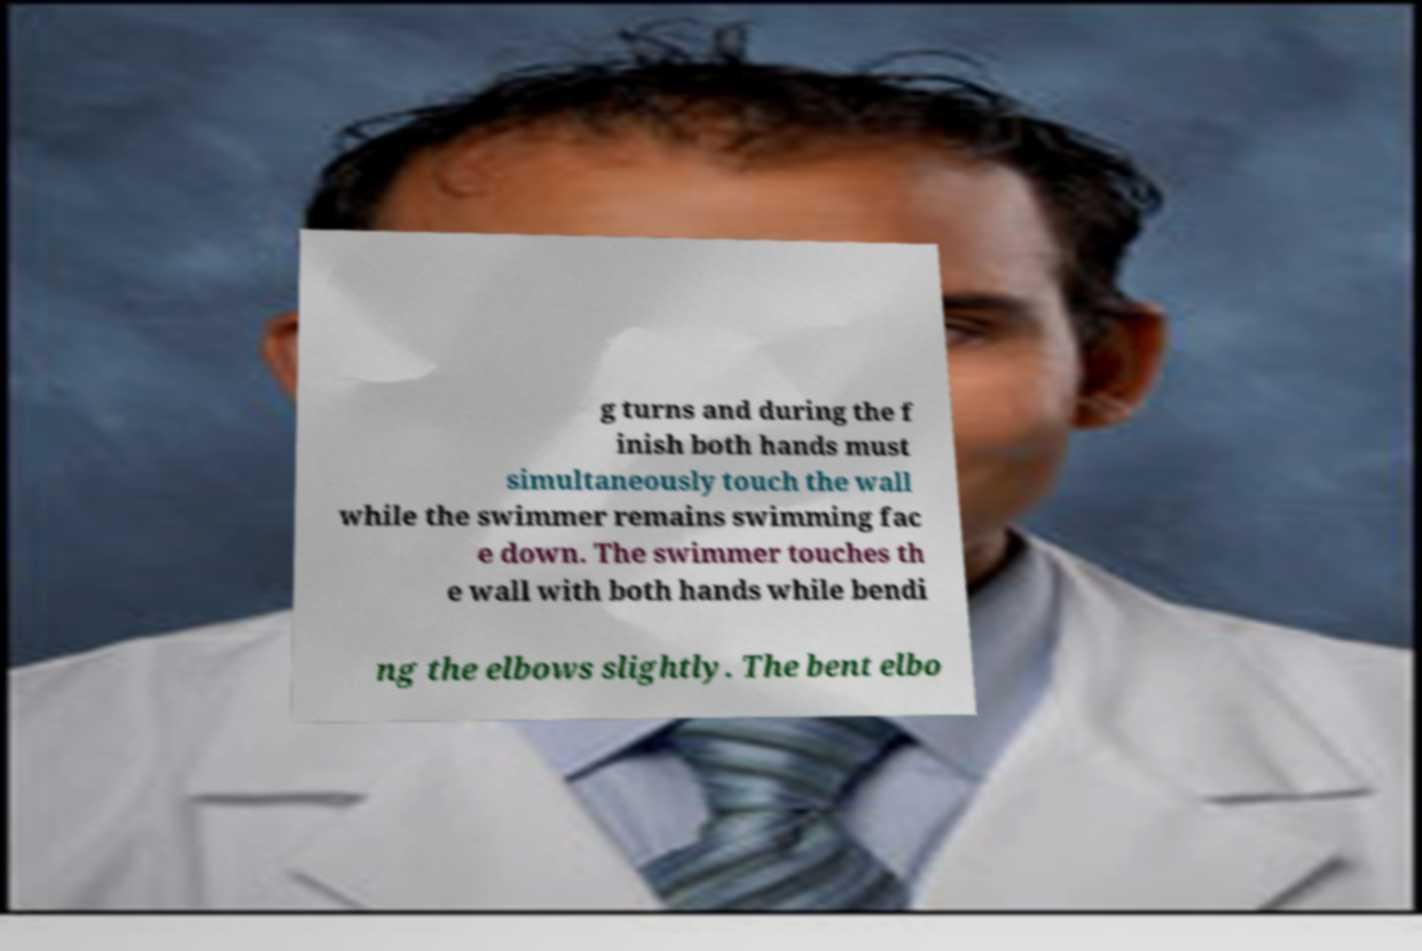Could you assist in decoding the text presented in this image and type it out clearly? g turns and during the f inish both hands must simultaneously touch the wall while the swimmer remains swimming fac e down. The swimmer touches th e wall with both hands while bendi ng the elbows slightly. The bent elbo 